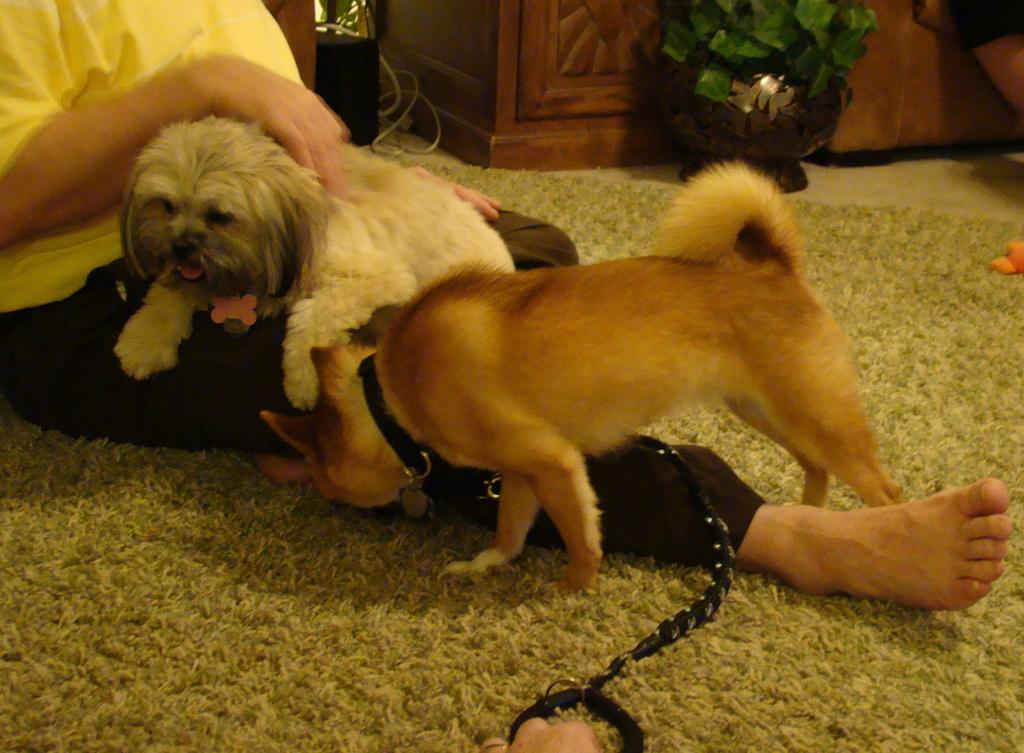What is the woman doing in the image? The woman is seated on the floor in the image. What animals are present in the image? There are dogs in the image. How are the dogs adorned in the image? The dogs have a string around their necks. What type of flooring is visible in the image? There is a carpet on the floor in the image. What type of furniture is present in the image? There is a cupboard in the image. What type of plant is visible in the image? There is a plant in the image. What type of fire can be seen in the image? There is no fire present in the image. What type of ghost is visible in the image? There is no ghost present in the image. 